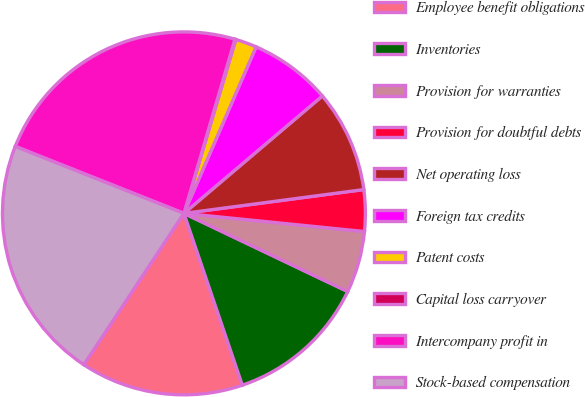<chart> <loc_0><loc_0><loc_500><loc_500><pie_chart><fcel>Employee benefit obligations<fcel>Inventories<fcel>Provision for warranties<fcel>Provision for doubtful debts<fcel>Net operating loss<fcel>Foreign tax credits<fcel>Patent costs<fcel>Capital loss carryover<fcel>Intercompany profit in<fcel>Stock-based compensation<nl><fcel>14.51%<fcel>12.7%<fcel>5.49%<fcel>3.69%<fcel>9.1%<fcel>7.3%<fcel>1.89%<fcel>0.08%<fcel>23.52%<fcel>21.72%<nl></chart> 